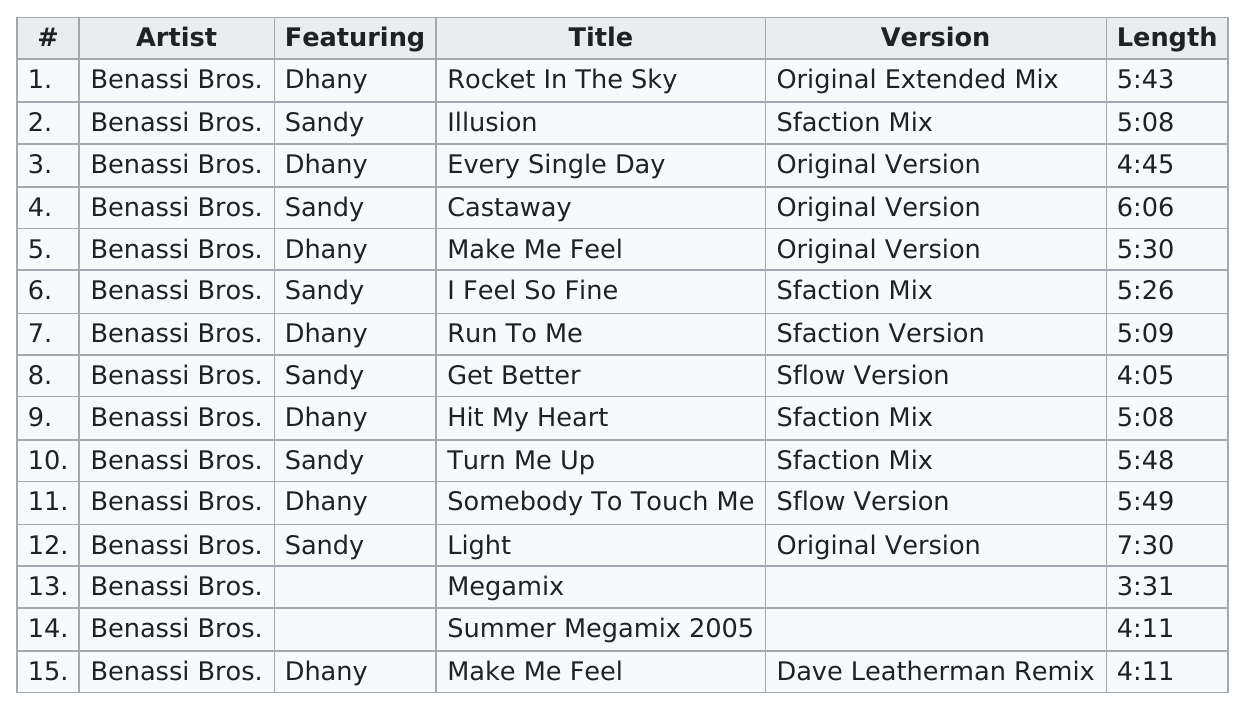List a handful of essential elements in this visual. The number of tracks on the Benassi Bros. greatest hits album released in 2005 was 15. The title of the last track on the Benassi Bros.' greatest hits album is "Make Me Feel. The total number of tracks on the Benassi Bros. greatest hits album is 15. Six tracks featured Sandy in total. There are 15 tracks on the 2005 Best of Benassi Bros. album. 